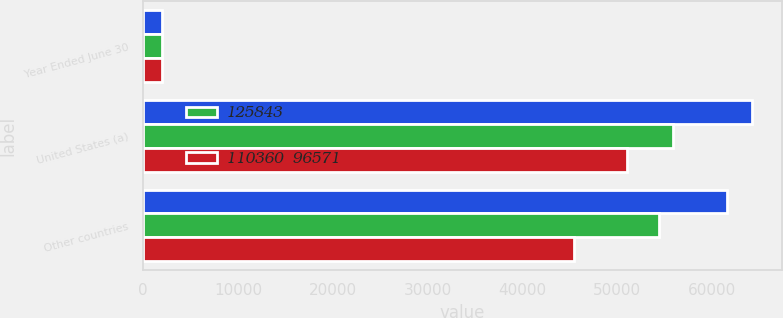Convert chart to OTSL. <chart><loc_0><loc_0><loc_500><loc_500><stacked_bar_chart><ecel><fcel>Year Ended June 30<fcel>United States (a)<fcel>Other countries<nl><fcel>nan<fcel>2019<fcel>64199<fcel>61644<nl><fcel>125843<fcel>2018<fcel>55926<fcel>54434<nl><fcel>110360  96571<fcel>2017<fcel>51078<fcel>45493<nl></chart> 